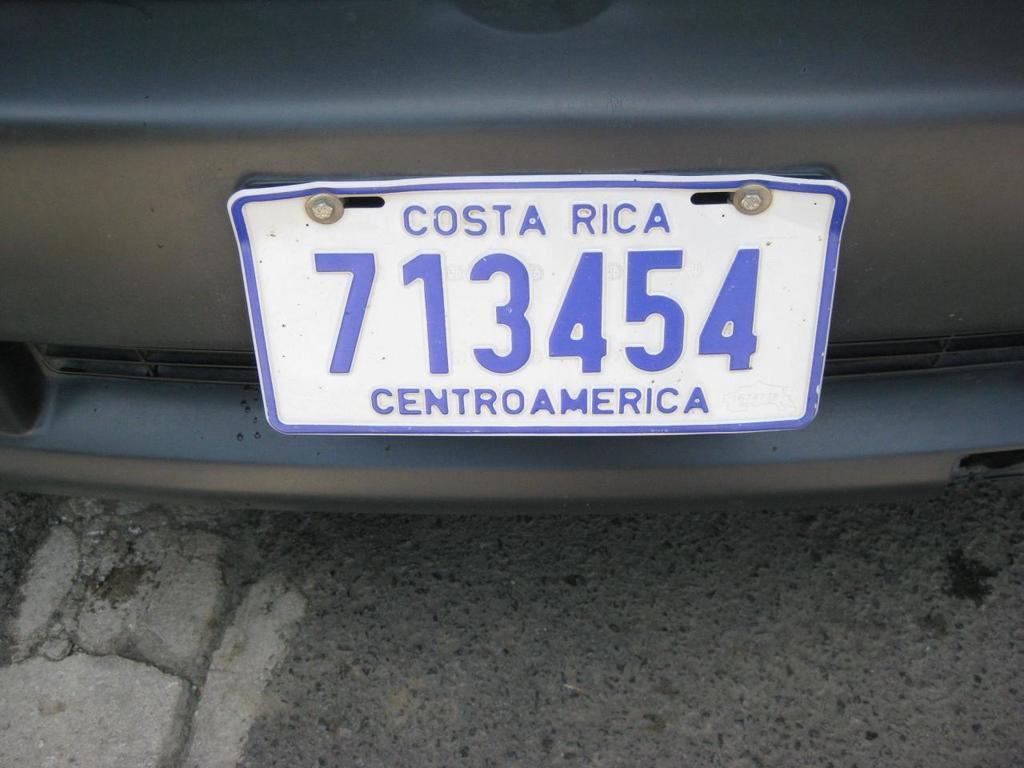Provide a one-sentence caption for the provided image. A Blue and white license plate from Costa Rica is screwed onto a dark grey bumper. 